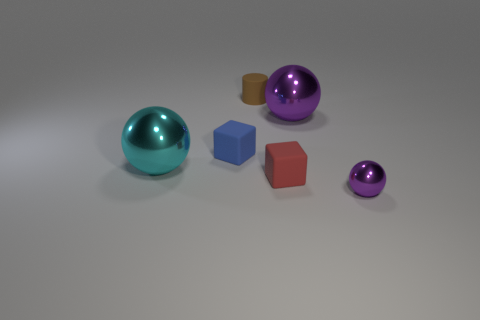Does the blue matte cube have the same size as the cyan sphere?
Give a very brief answer. No. How big is the cylinder?
Give a very brief answer. Small. What number of cylinders are either small brown rubber objects or big cyan metallic objects?
Your response must be concise. 1. What is the size of the cyan object that is the same shape as the large purple thing?
Your answer should be compact. Large. How many green matte blocks are there?
Give a very brief answer. 0. Is the shape of the cyan shiny thing the same as the large thing on the right side of the rubber cylinder?
Provide a short and direct response. Yes. There is a purple object that is to the left of the tiny purple object; what is its size?
Your answer should be compact. Large. What material is the blue object?
Provide a succinct answer. Rubber. There is a large metal object behind the cyan ball; is its shape the same as the small red rubber thing?
Your answer should be very brief. No. What size is the object that is the same color as the tiny metal sphere?
Provide a short and direct response. Large. 